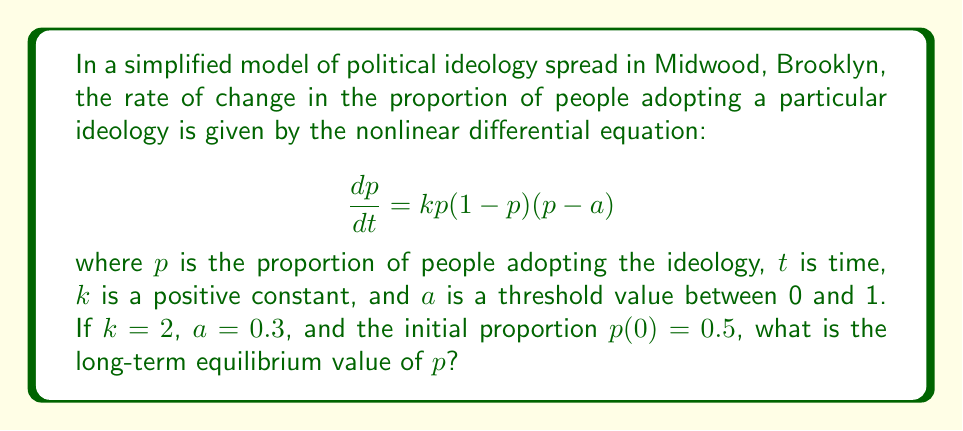Can you solve this math problem? To find the long-term equilibrium value of $p$, we need to follow these steps:

1) First, we identify the equilibrium points of the system. These occur when $\frac{dp}{dt} = 0$. From the given equation:

   $$\frac{dp}{dt} = kp(1-p)(p-a) = 0$$

2) This equation is satisfied when $p=0$, $p=1$, or $p=a$. These are our three equilibrium points.

3) To determine which equilibrium point the system will approach in the long term, we need to analyze the stability of these points. We can do this by examining the sign of $\frac{dp}{dt}$ near each point.

4) For $p=0$: 
   When $p$ is slightly larger than 0, $\frac{dp}{dt} < 0$, so $p$ decreases towards 0.
   
5) For $p=a=0.3$: 
   When $p < 0.3$, $\frac{dp}{dt} < 0$, so $p$ decreases away from 0.3.
   When $p > 0.3$, $\frac{dp}{dt} > 0$, so $p$ increases away from 0.3.
   This indicates that $p=0.3$ is an unstable equilibrium.

6) For $p=1$: 
   When $p$ is slightly less than 1, $\frac{dp}{dt} > 0$, so $p$ increases towards 1.

7) Given that the initial condition $p(0)=0.5$ is greater than both 0 and 0.3, the system will approach the stable equilibrium at $p=1$ in the long term.

Therefore, the long-term equilibrium value of $p$ is 1.
Answer: 1 